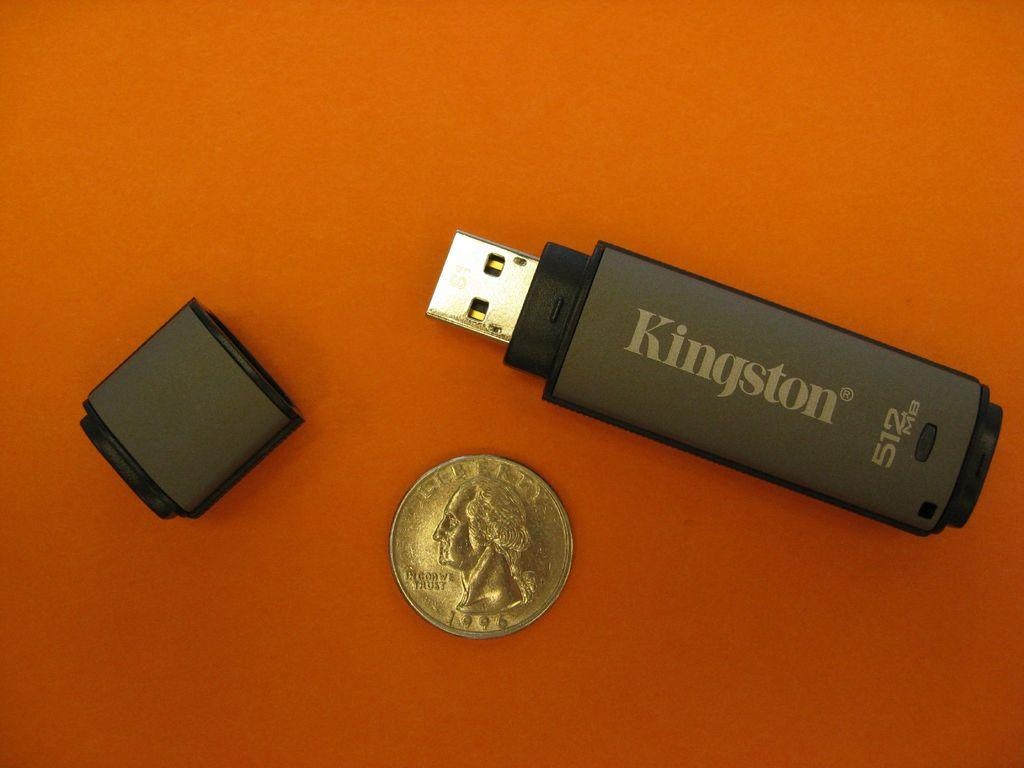<image>
Describe the image concisely. a Kingston thumb drive next to a Quarter coin 